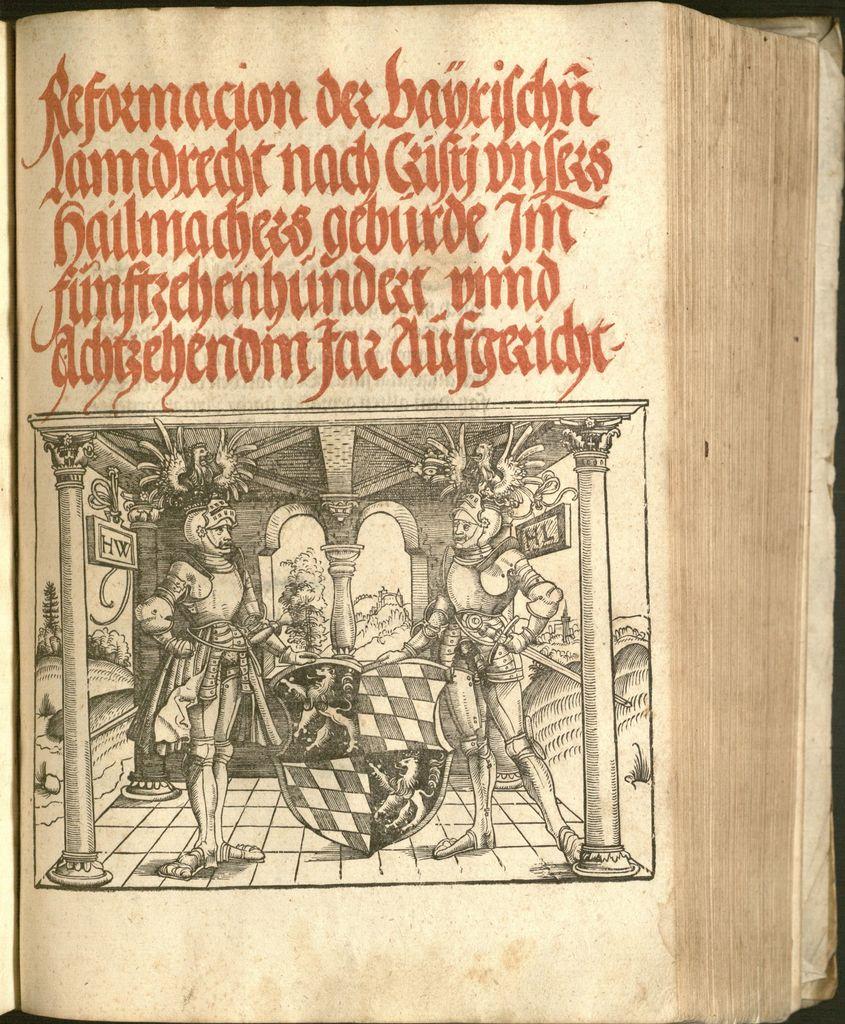What is the first word on this page?
Your answer should be compact. Reformacion. 